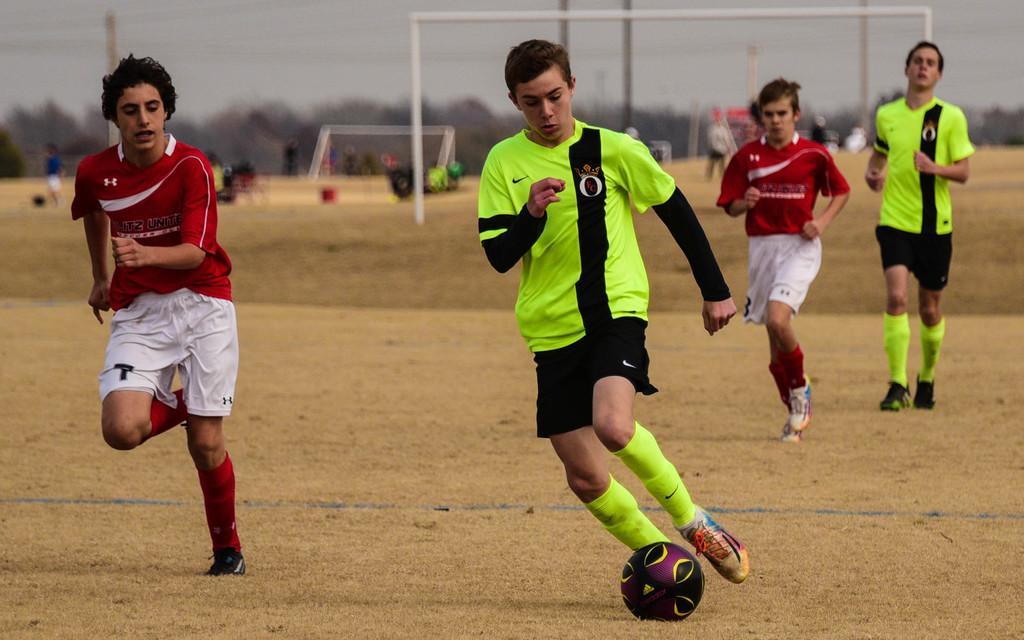Please provide a concise description of this image. In the image we can see there are people who are standing on the ground and they are playing with football and they are wearing the uniform. 